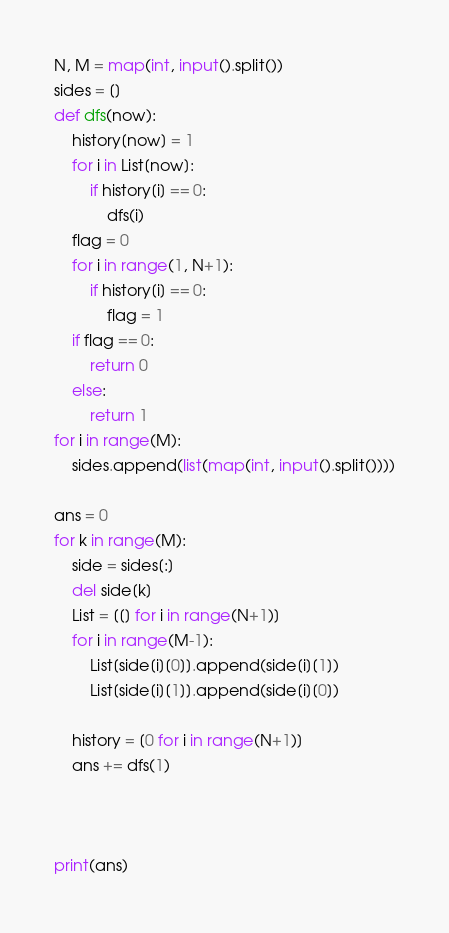Convert code to text. <code><loc_0><loc_0><loc_500><loc_500><_Python_>N, M = map(int, input().split())
sides = []
def dfs(now):
    history[now] = 1
    for i in List[now]:
        if history[i] == 0:
            dfs(i)
    flag = 0
    for i in range(1, N+1):
        if history[i] == 0:
            flag = 1
    if flag == 0:
        return 0
    else:
        return 1
for i in range(M):
    sides.append(list(map(int, input().split())))

ans = 0
for k in range(M):
    side = sides[:]
    del side[k]
    List = [[] for i in range(N+1)]
    for i in range(M-1):
        List[side[i][0]].append(side[i][1])
        List[side[i][1]].append(side[i][0])

    history = [0 for i in range(N+1)]
    ans += dfs(1)



print(ans)
</code> 